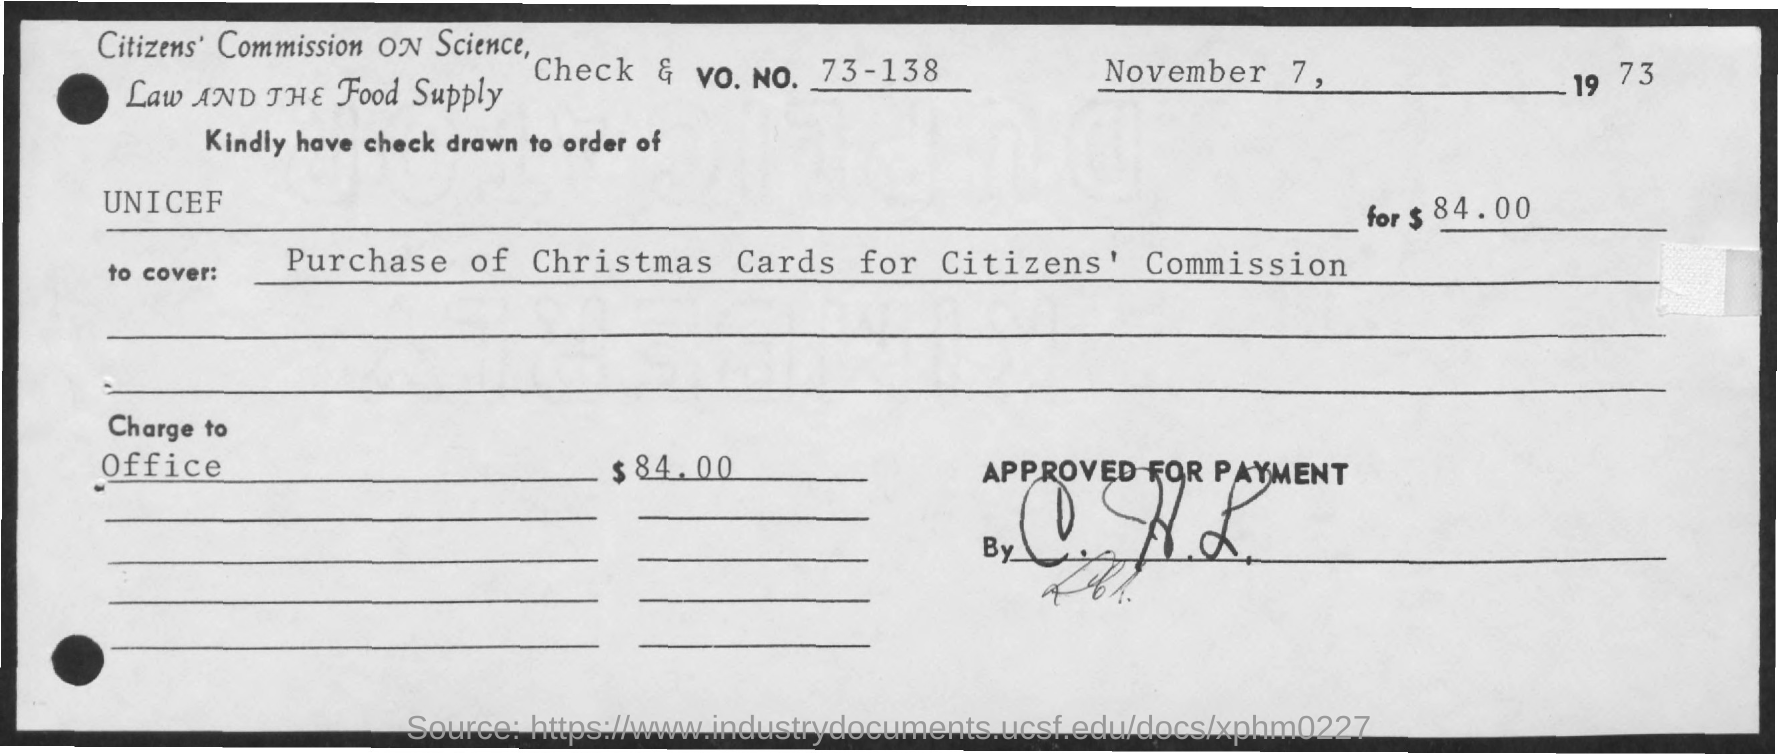Give some essential details in this illustration. The check is payable in the name of UNICEF. The Vo. No. mentioned in the check is 73 - 138. The amount of the check is $84.00. The check dated November 7, 1973, has been inserted into a brochure. 